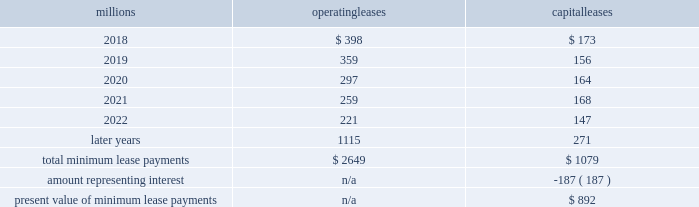17 .
Leases we lease certain locomotives , freight cars , and other property .
The consolidated statements of financial position as of december 31 , 2017 , and 2016 included $ 1635 million , net of $ 953 million of accumulated depreciation , and $ 1997 million , net of $ 1121 million of accumulated depreciation , respectively , for properties held under capital leases .
A charge to income resulting from the depreciation for assets held under capital leases is included within depreciation expense in our consolidated statements of income .
Future minimum lease payments for operating and capital leases with initial or remaining non-cancelable lease terms in excess of one year as of december 31 , 2017 , were as follows : millions operating leases capital leases .
Approximately 97% ( 97 % ) of capital lease payments relate to locomotives .
Rent expense for operating leases with terms exceeding one month was $ 480 million in 2017 , $ 535 million in 2016 , and $ 590 million in 2015 .
When cash rental payments are not made on a straight-line basis , we recognize variable rental expense on a straight-line basis over the lease term .
Contingent rentals and sub-rentals are not significant .
18 .
Commitments and contingencies asserted and unasserted claims 2013 various claims and lawsuits are pending against us and certain of our subsidiaries .
We cannot fully determine the effect of all asserted and unasserted claims on our consolidated results of operations , financial condition , or liquidity .
To the extent possible , we have recorded a liability where asserted and unasserted claims are considered probable and where such claims can be reasonably estimated .
We do not expect that any known lawsuits , claims , environmental costs , commitments , contingent liabilities , or guarantees will have a material adverse effect on our consolidated results of operations , financial condition , or liquidity after taking into account liabilities and insurance recoveries previously recorded for these matters .
Personal injury 2013 the cost of personal injuries to employees and others related to our activities is charged to expense based on estimates of the ultimate cost and number of incidents each year .
We use an actuarial analysis to measure the expense and liability , including unasserted claims .
The federal employers 2019 liability act ( fela ) governs compensation for work-related accidents .
Under fela , damages are assessed based on a finding of fault through litigation or out-of-court settlements .
We offer a comprehensive variety of services and rehabilitation programs for employees who are injured at work .
Our personal injury liability is not discounted to present value due to the uncertainty surrounding the timing of future payments .
Approximately 95% ( 95 % ) of the recorded liability is related to asserted claims and approximately 5% ( 5 % ) is related to unasserted claims at december 31 , 2017 .
Because of the uncertainty surrounding the ultimate outcome of personal injury claims , it is reasonably possible that future costs to settle these claims may range from approximately $ 285 million to $ 310 million .
We record an accrual at the low end of the range as no amount of loss within the range is more probable than any other .
Estimates can vary over time due to evolving trends in litigation. .
As of december 31 , 2017 what was the percent of the total non-cancelable lease terms in excess of one year due in 2019? 
Computations: ((359 + 156) / (2649 + 1079))
Answer: 0.13814. 17 .
Leases we lease certain locomotives , freight cars , and other property .
The consolidated statements of financial position as of december 31 , 2017 , and 2016 included $ 1635 million , net of $ 953 million of accumulated depreciation , and $ 1997 million , net of $ 1121 million of accumulated depreciation , respectively , for properties held under capital leases .
A charge to income resulting from the depreciation for assets held under capital leases is included within depreciation expense in our consolidated statements of income .
Future minimum lease payments for operating and capital leases with initial or remaining non-cancelable lease terms in excess of one year as of december 31 , 2017 , were as follows : millions operating leases capital leases .
Approximately 97% ( 97 % ) of capital lease payments relate to locomotives .
Rent expense for operating leases with terms exceeding one month was $ 480 million in 2017 , $ 535 million in 2016 , and $ 590 million in 2015 .
When cash rental payments are not made on a straight-line basis , we recognize variable rental expense on a straight-line basis over the lease term .
Contingent rentals and sub-rentals are not significant .
18 .
Commitments and contingencies asserted and unasserted claims 2013 various claims and lawsuits are pending against us and certain of our subsidiaries .
We cannot fully determine the effect of all asserted and unasserted claims on our consolidated results of operations , financial condition , or liquidity .
To the extent possible , we have recorded a liability where asserted and unasserted claims are considered probable and where such claims can be reasonably estimated .
We do not expect that any known lawsuits , claims , environmental costs , commitments , contingent liabilities , or guarantees will have a material adverse effect on our consolidated results of operations , financial condition , or liquidity after taking into account liabilities and insurance recoveries previously recorded for these matters .
Personal injury 2013 the cost of personal injuries to employees and others related to our activities is charged to expense based on estimates of the ultimate cost and number of incidents each year .
We use an actuarial analysis to measure the expense and liability , including unasserted claims .
The federal employers 2019 liability act ( fela ) governs compensation for work-related accidents .
Under fela , damages are assessed based on a finding of fault through litigation or out-of-court settlements .
We offer a comprehensive variety of services and rehabilitation programs for employees who are injured at work .
Our personal injury liability is not discounted to present value due to the uncertainty surrounding the timing of future payments .
Approximately 95% ( 95 % ) of the recorded liability is related to asserted claims and approximately 5% ( 5 % ) is related to unasserted claims at december 31 , 2017 .
Because of the uncertainty surrounding the ultimate outcome of personal injury claims , it is reasonably possible that future costs to settle these claims may range from approximately $ 285 million to $ 310 million .
We record an accrual at the low end of the range as no amount of loss within the range is more probable than any other .
Estimates can vary over time due to evolving trends in litigation. .
What percentage of total minimum lease payments are operating leases? 
Computations: (2649 / (2649 + 1079))
Answer: 0.71057. 